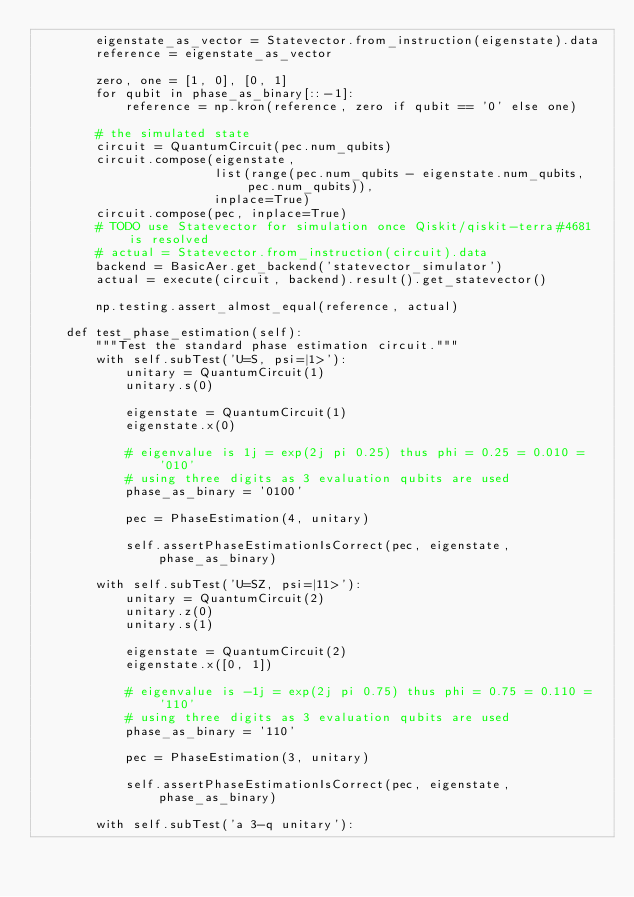Convert code to text. <code><loc_0><loc_0><loc_500><loc_500><_Python_>        eigenstate_as_vector = Statevector.from_instruction(eigenstate).data
        reference = eigenstate_as_vector

        zero, one = [1, 0], [0, 1]
        for qubit in phase_as_binary[::-1]:
            reference = np.kron(reference, zero if qubit == '0' else one)

        # the simulated state
        circuit = QuantumCircuit(pec.num_qubits)
        circuit.compose(eigenstate,
                        list(range(pec.num_qubits - eigenstate.num_qubits, pec.num_qubits)),
                        inplace=True)
        circuit.compose(pec, inplace=True)
        # TODO use Statevector for simulation once Qiskit/qiskit-terra#4681 is resolved
        # actual = Statevector.from_instruction(circuit).data
        backend = BasicAer.get_backend('statevector_simulator')
        actual = execute(circuit, backend).result().get_statevector()

        np.testing.assert_almost_equal(reference, actual)

    def test_phase_estimation(self):
        """Test the standard phase estimation circuit."""
        with self.subTest('U=S, psi=|1>'):
            unitary = QuantumCircuit(1)
            unitary.s(0)

            eigenstate = QuantumCircuit(1)
            eigenstate.x(0)

            # eigenvalue is 1j = exp(2j pi 0.25) thus phi = 0.25 = 0.010 = '010'
            # using three digits as 3 evaluation qubits are used
            phase_as_binary = '0100'

            pec = PhaseEstimation(4, unitary)

            self.assertPhaseEstimationIsCorrect(pec, eigenstate, phase_as_binary)

        with self.subTest('U=SZ, psi=|11>'):
            unitary = QuantumCircuit(2)
            unitary.z(0)
            unitary.s(1)

            eigenstate = QuantumCircuit(2)
            eigenstate.x([0, 1])

            # eigenvalue is -1j = exp(2j pi 0.75) thus phi = 0.75 = 0.110 = '110'
            # using three digits as 3 evaluation qubits are used
            phase_as_binary = '110'

            pec = PhaseEstimation(3, unitary)

            self.assertPhaseEstimationIsCorrect(pec, eigenstate, phase_as_binary)

        with self.subTest('a 3-q unitary'):</code> 